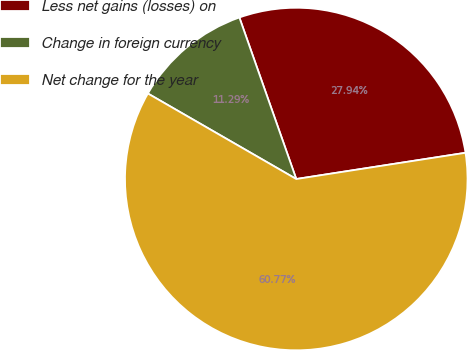Convert chart to OTSL. <chart><loc_0><loc_0><loc_500><loc_500><pie_chart><fcel>Less net gains (losses) on<fcel>Change in foreign currency<fcel>Net change for the year<nl><fcel>27.94%<fcel>11.29%<fcel>60.77%<nl></chart> 